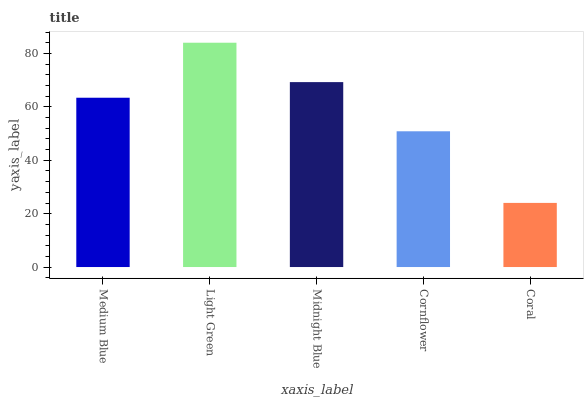Is Coral the minimum?
Answer yes or no. Yes. Is Light Green the maximum?
Answer yes or no. Yes. Is Midnight Blue the minimum?
Answer yes or no. No. Is Midnight Blue the maximum?
Answer yes or no. No. Is Light Green greater than Midnight Blue?
Answer yes or no. Yes. Is Midnight Blue less than Light Green?
Answer yes or no. Yes. Is Midnight Blue greater than Light Green?
Answer yes or no. No. Is Light Green less than Midnight Blue?
Answer yes or no. No. Is Medium Blue the high median?
Answer yes or no. Yes. Is Medium Blue the low median?
Answer yes or no. Yes. Is Coral the high median?
Answer yes or no. No. Is Coral the low median?
Answer yes or no. No. 